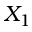<formula> <loc_0><loc_0><loc_500><loc_500>X _ { 1 }</formula> 